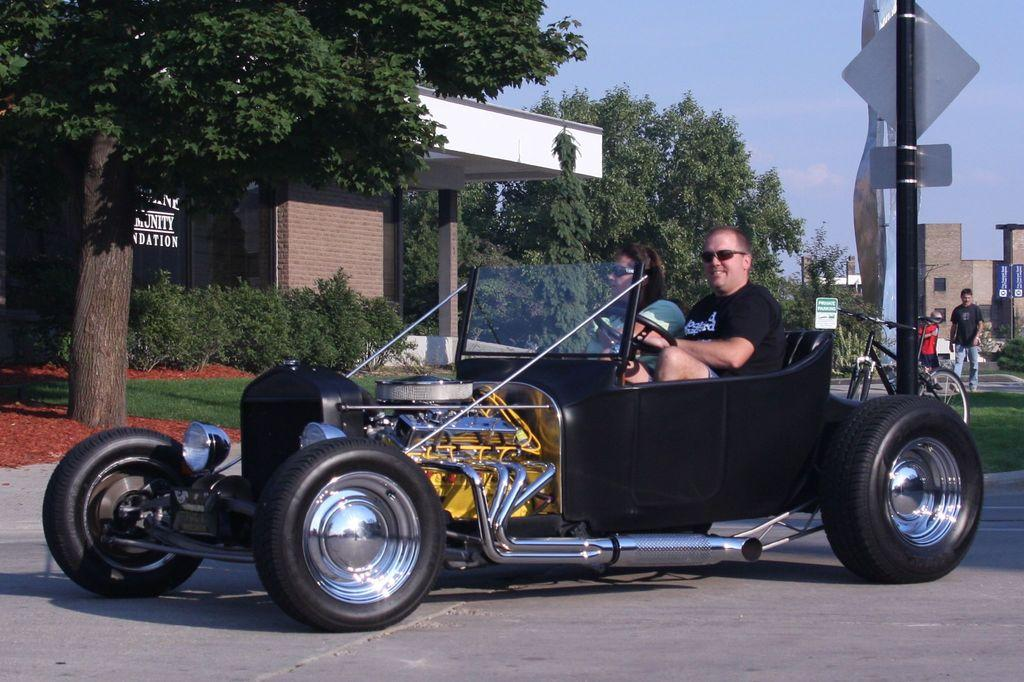What is the main subject of the image? The main subject of the image is a car. Who or what is inside the car? Two people are seated in the car. What is happening on the sidewalk in the image? There is a man walking on the sidewalk. What other mode of transportation can be seen in the image? There is a bicycle in the image. What type of buildings are visible in the image? There are houses visible in the image. What type of vegetation is present in the image? There are trees present in the image. What type of servant is attending to the car in the image? There is no servant present in the image. What does the taste of the trees in the image suggest about their flavor? Trees do not have a taste, as they are not edible. 